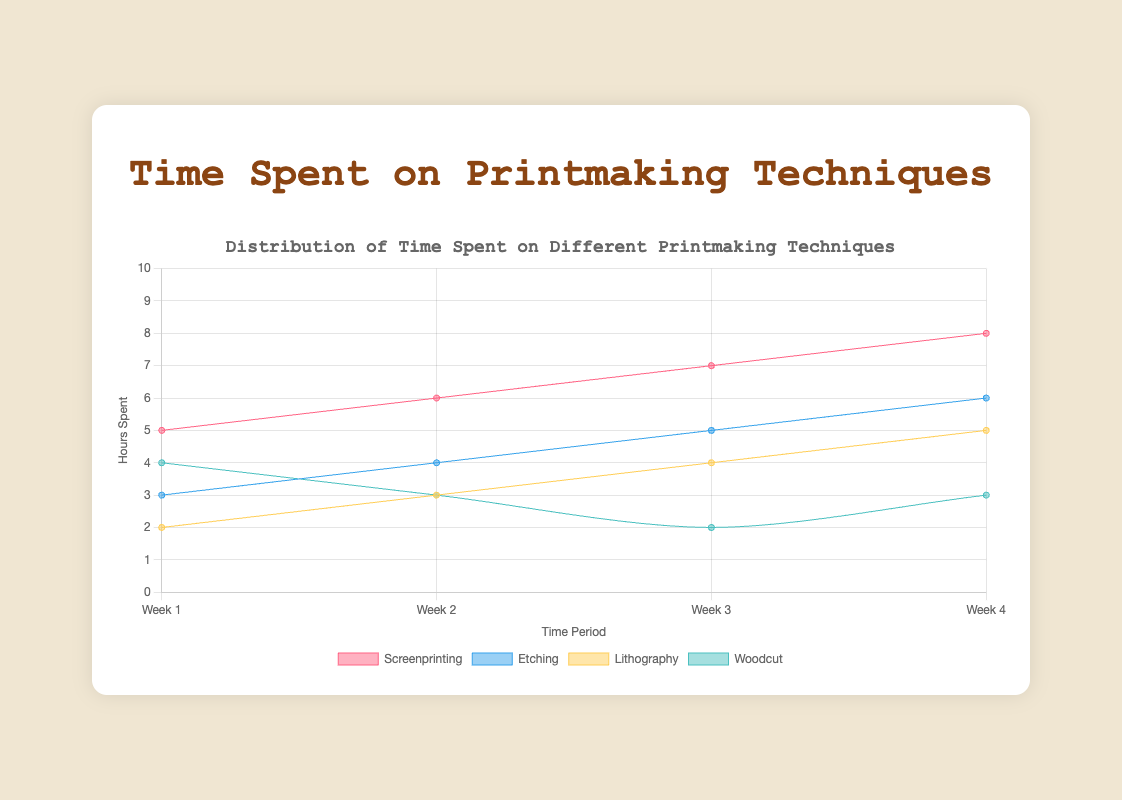What is the title of the chart? The title is usually displayed at the top of the chart and gives a brief description of what the chart represents. Here, it's "Time Spent on Printmaking Techniques."
Answer: Time Spent on Printmaking Techniques What are the labels on the x-axis and y-axis? The x-axis label tells us what the data points along the horizontal axis represent, which is "Time Period". The y-axis label describes the vertical data points, which is "Hours Spent".
Answer: Time Period, Hours Spent Which printmaking technique had the highest hours spent in Week 4? To find this, look at the data points for Week 4 and identify which technique has the highest value. Screenprinting had 8 hours, which is the highest among the techniques for Week 4.
Answer: Screenprinting What is the total time spent on Woodcut techniques throughout all four weeks? Sum up the time spent on Woodcut for all weeks: 4 (Week 1) + 3 (Week 2) + 2 (Week 3) + 3 (Week 4) = 12 hours.
Answer: 12 hours Which technique saw an increase in time spent every week? Review the lines for each technique across the weeks. Screenprinting consistently increased from Week 1 to Week 4 (5, 6, 7, 8).
Answer: Screenprinting Compare the time spent on Etching in Week 1 and Week 4. What is the difference? Subtract the hours spent on Etching in Week 1 from the hours spent in Week 4: 6 (Week 4) - 3 (Week 1) = 3.
Answer: 3 Which technique had the least time spent in Week 3? Look at the values for Week 3 and identify the minimum value, which is Lithography with 2 hours.
Answer: Lithography Calculate the average time spent on Lithography over the four weeks. Find the sum of the time spent on Lithography and divide by 4: (2 + 3 + 4 + 5)/4 = 14/4 = 3.5.
Answer: 3.5 Did the time spent on Woodcut techniques fluctuate over the weeks? Analyze the trend of the Woodcut line: it starts at 4, drops to 3, then 2, and goes back up to 3, indicating fluctuation.
Answer: Yes Identify the trend in time spent on Etching from Week 1 to Week 4. The time spent on Etching increased progressively from 3, 4, 5, to 6 hours.
Answer: Increasing 